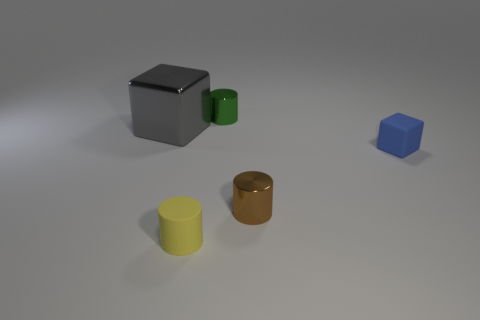Is the size of the green object the same as the matte cylinder?
Provide a succinct answer. Yes. What number of other objects are there of the same size as the metal block?
Offer a very short reply. 0. How many things are metal cylinders that are behind the large gray block or small things that are behind the tiny yellow rubber thing?
Your response must be concise. 3. There is a green shiny object that is the same size as the yellow matte object; what is its shape?
Give a very brief answer. Cylinder. There is a gray block that is made of the same material as the brown object; what is its size?
Your answer should be compact. Large. Is the shape of the big gray thing the same as the brown object?
Keep it short and to the point. No. There is a rubber cube that is the same size as the yellow matte thing; what color is it?
Make the answer very short. Blue. There is a matte thing that is the same shape as the large metallic thing; what size is it?
Offer a terse response. Small. The blue object that is to the right of the gray metallic object has what shape?
Offer a terse response. Cube. Does the small green metallic object have the same shape as the tiny rubber thing that is on the right side of the tiny green thing?
Keep it short and to the point. No. 